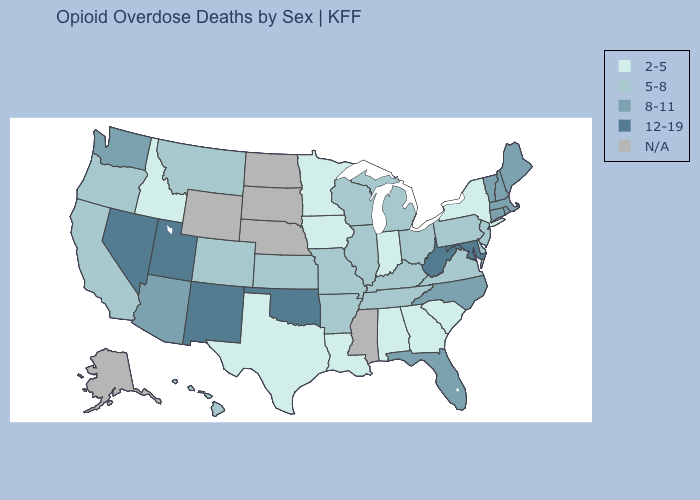What is the highest value in states that border Nebraska?
Answer briefly. 5-8. Does Georgia have the lowest value in the USA?
Short answer required. Yes. Name the states that have a value in the range 12-19?
Quick response, please. Maryland, Nevada, New Mexico, Oklahoma, Utah, West Virginia. Does the first symbol in the legend represent the smallest category?
Answer briefly. Yes. Name the states that have a value in the range 8-11?
Write a very short answer. Arizona, Connecticut, Florida, Maine, Massachusetts, New Hampshire, North Carolina, Rhode Island, Vermont, Washington. Does the first symbol in the legend represent the smallest category?
Concise answer only. Yes. What is the value of North Carolina?
Write a very short answer. 8-11. Name the states that have a value in the range 12-19?
Short answer required. Maryland, Nevada, New Mexico, Oklahoma, Utah, West Virginia. Which states have the highest value in the USA?
Write a very short answer. Maryland, Nevada, New Mexico, Oklahoma, Utah, West Virginia. What is the value of New Hampshire?
Answer briefly. 8-11. Name the states that have a value in the range N/A?
Give a very brief answer. Alaska, Mississippi, Nebraska, North Dakota, South Dakota, Wyoming. What is the value of Delaware?
Quick response, please. 5-8. Which states have the lowest value in the USA?
Be succinct. Alabama, Georgia, Idaho, Indiana, Iowa, Louisiana, Minnesota, New York, South Carolina, Texas. What is the highest value in states that border West Virginia?
Concise answer only. 12-19. 